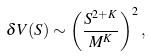Convert formula to latex. <formula><loc_0><loc_0><loc_500><loc_500>\delta V ( S ) \sim \left ( \frac { S ^ { 2 + K } } { M ^ { K } } \right ) ^ { 2 } ,</formula> 